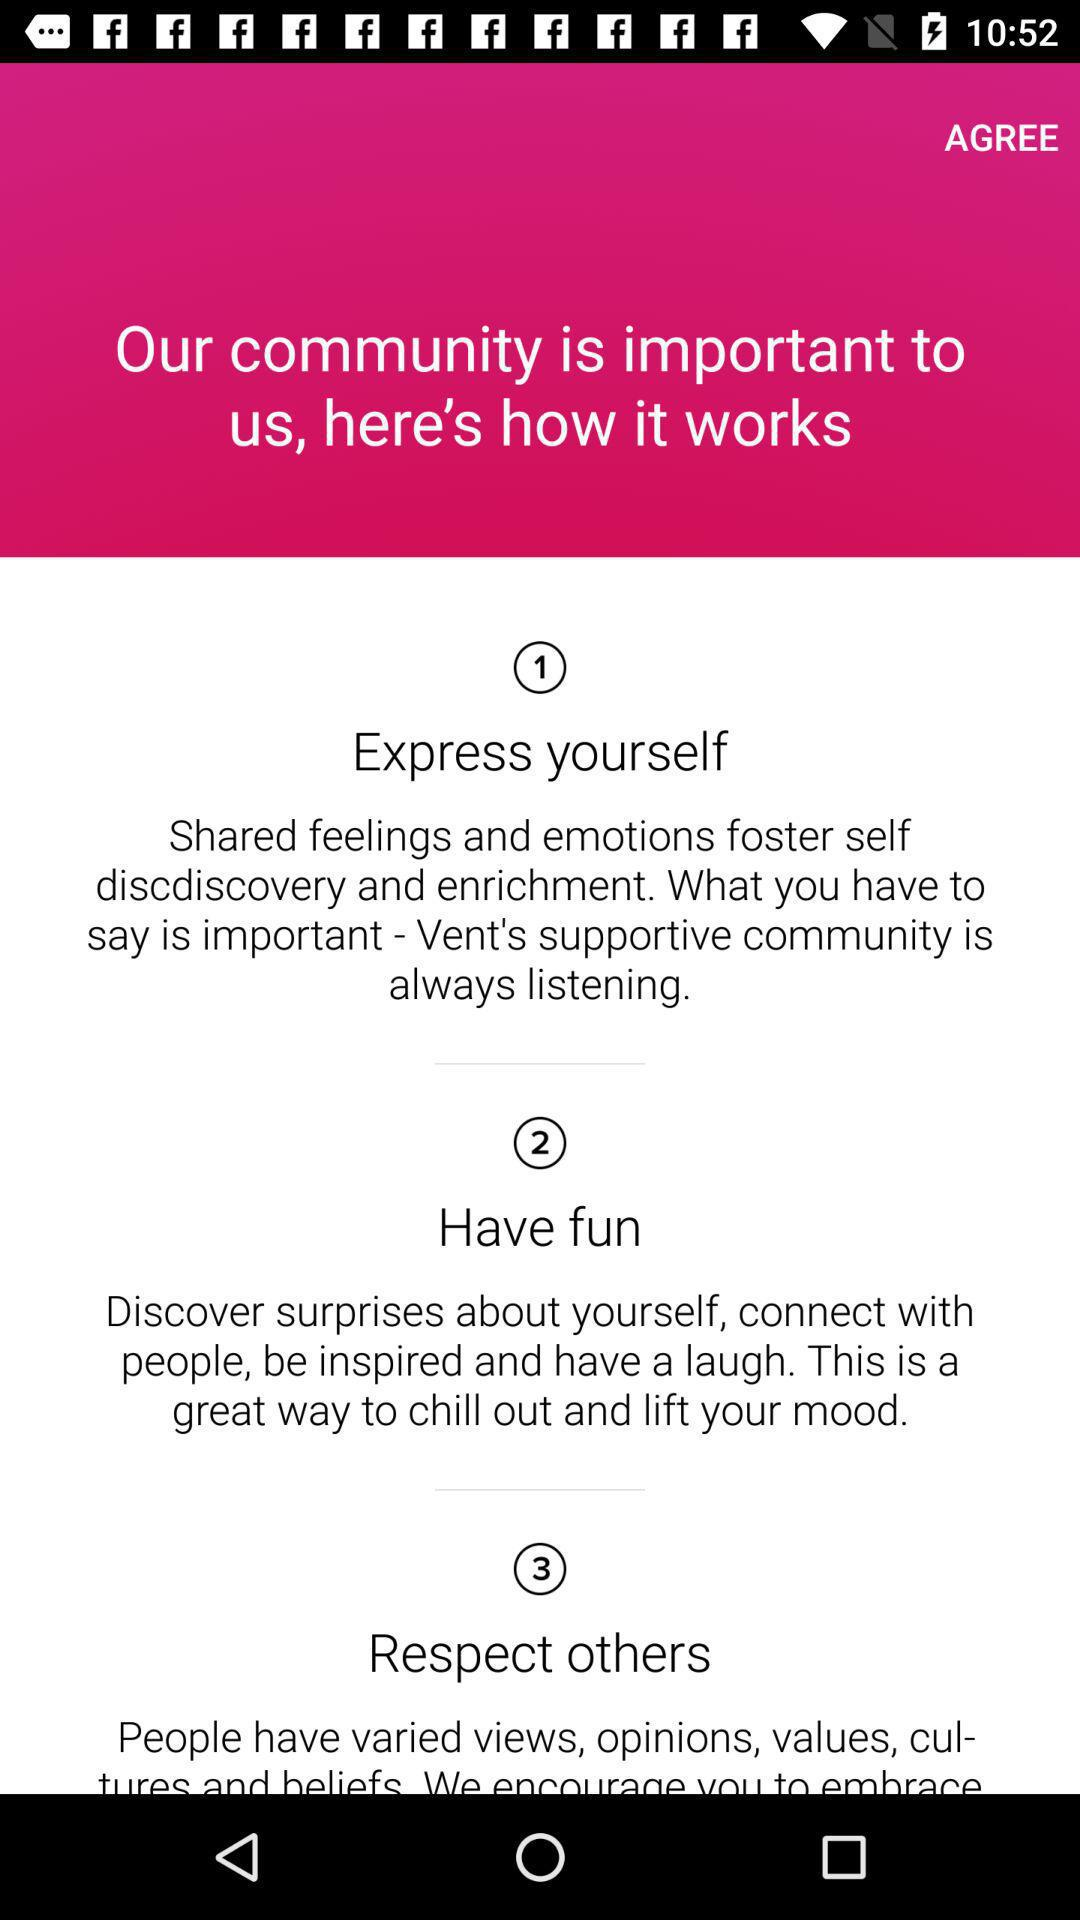How does the community work? The community works in the following ways, i.e. "Express yourself", "Have fun" and "Respect others". 